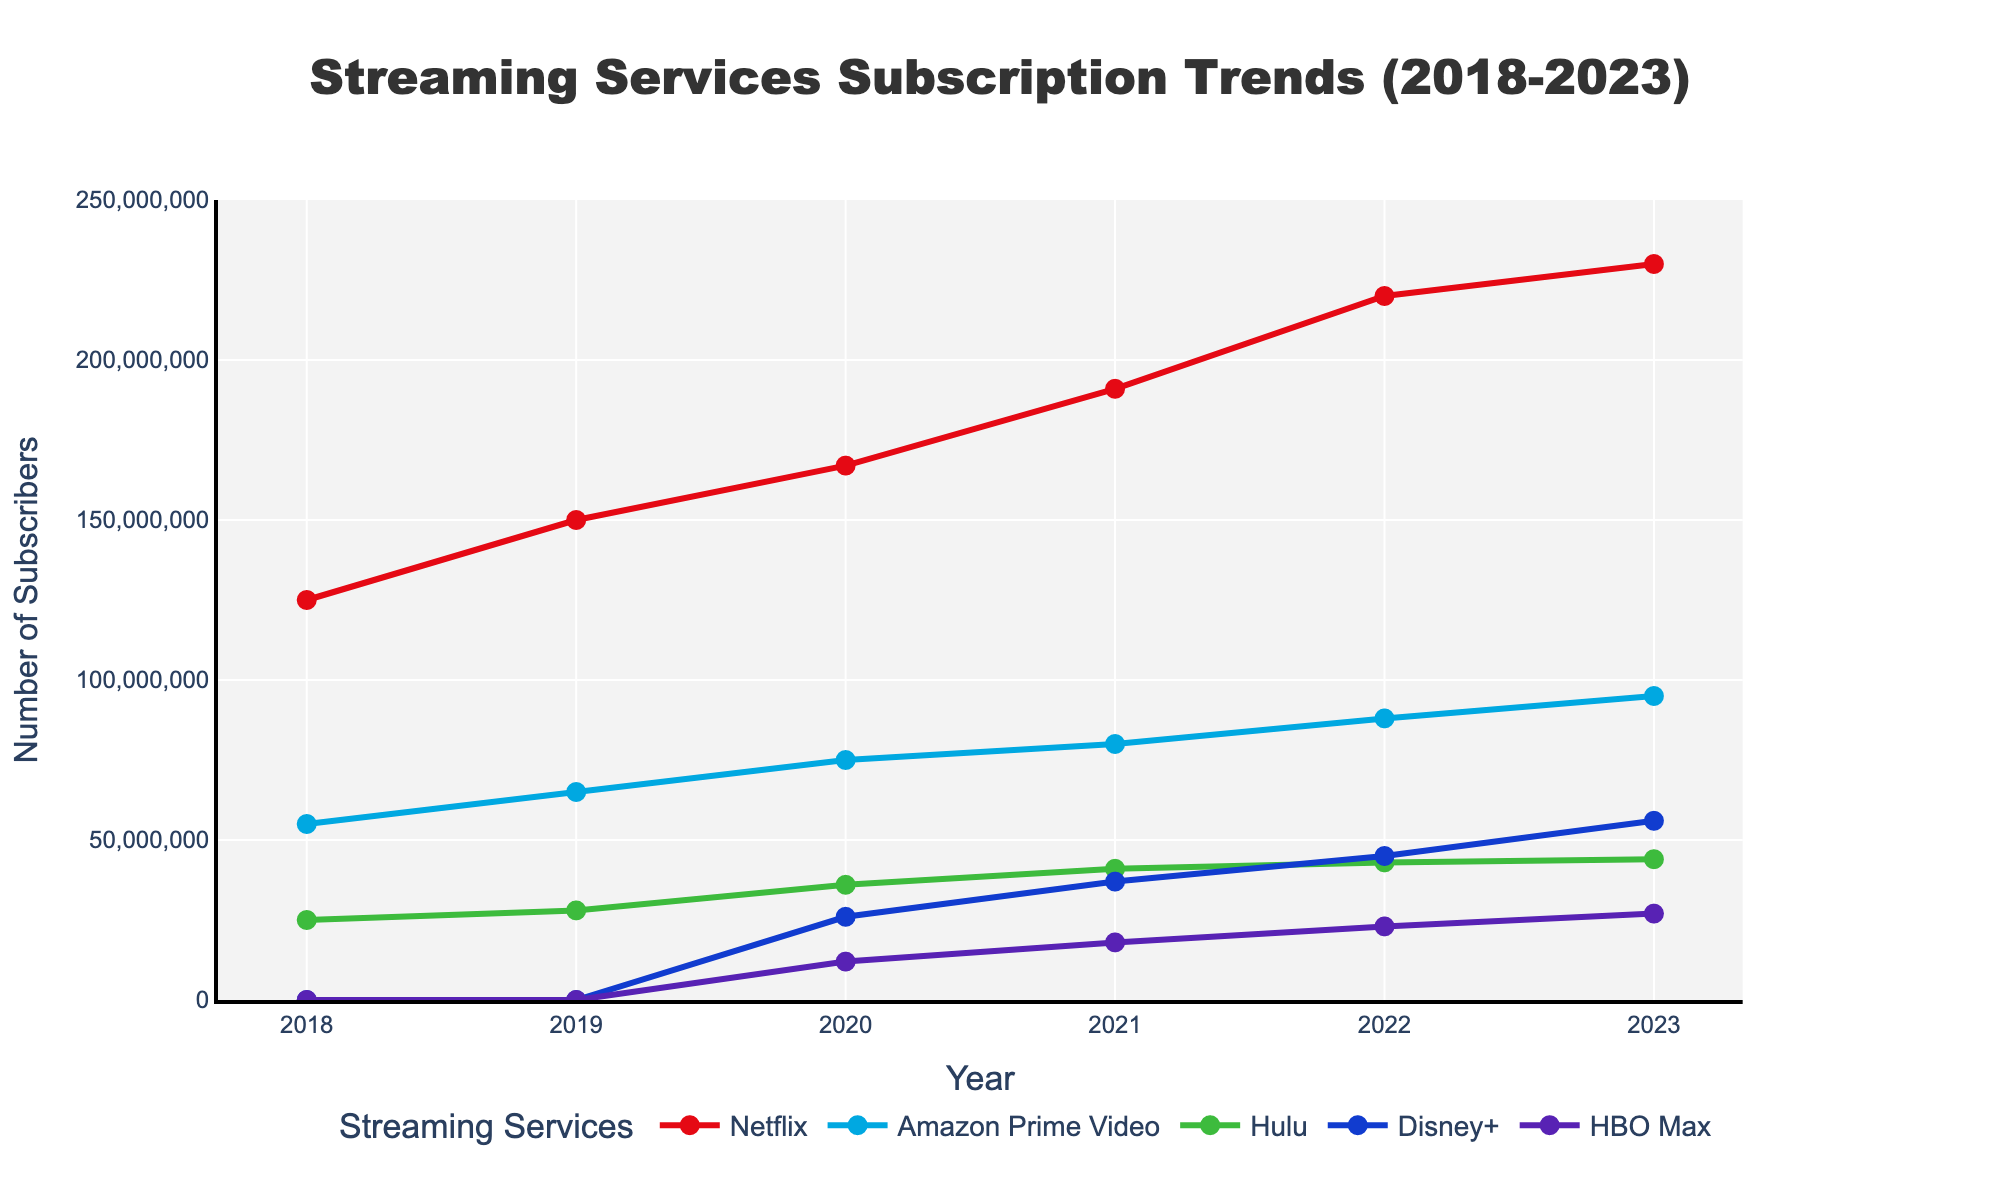How many streaming services are compared in the figure? The figure compares subscription numbers for various streaming services, indicated by five different colored lines. Count the number of unique services listed in the legend at the bottom.
Answer: 5 What is the title of the figure? The title is generally located at the top of the figure, conveying the main message or the focus of the data being visualized. Look at the centered text at the top.
Answer: Streaming Services Subscription Trends (2018-2023) Which streaming service saw the highest subscription growth between 2018 and 2023? To determine this, calculate the difference in subscriber numbers from 2018 to 2023 for each streaming service. The largest difference indicates the highest growth. Netflix starts at 125M and ends at 230M (105M growth), which is the highest among all.
Answer: Netflix What year did Disney+ first appear in the subscription data? Look at the timeline and identify the first year with a non-zero subscription number for Disney+. Disney+ starts appearing in the data from the year 2020.
Answer: 2020 Which streaming service had the least number of subscribers in 2023? To find out, compare the subscriber counts for all streaming services in 2023. HBO Max, with 27M subscribers, has the least among all.
Answer: HBO Max By what percentage did Hulu's subscribers increase from 2018 to 2023? First, find the initial and final subscriber numbers for Hulu, which are 25M in 2018 and 44M in 2023. Calculate the increase: (44M - 25M) = 19M. Then, determine the percentage increase: (19M/25M) * 100 ≈ 76%.
Answer: 76% How many streaming services had over 50 million subscribers in 2023? Check each service’s subscriber count in 2023. Netflix, Amazon Prime Video, and Disney+ surpassed 50M subscribers. Count these services.
Answer: 3 What pattern do HBO Max subscriptions follow from 2020 to 2023? Observe the data points for HBO Max from 2020 (12M) to 2023 (27M). The values increase year by year.
Answer: Increasing trend Compare the subscription counts of Netflix and Disney+ in 2020. Which had more subscribers, and by how much? Netflix had 167M and Disney+ had 26M subscribers in 2020. Subtract the two to find the difference: 167M - 26M = 141M.
Answer: Netflix, by 141M Which year did Netflix have the smallest increase in subscribers compared to the previous year? Calculate the year-over-year growth for Netflix from 2018 to 2023, and identify the smallest increase. The increase was smallest from 2022 to 2023 (10M).
Answer: 2022 to 2023 